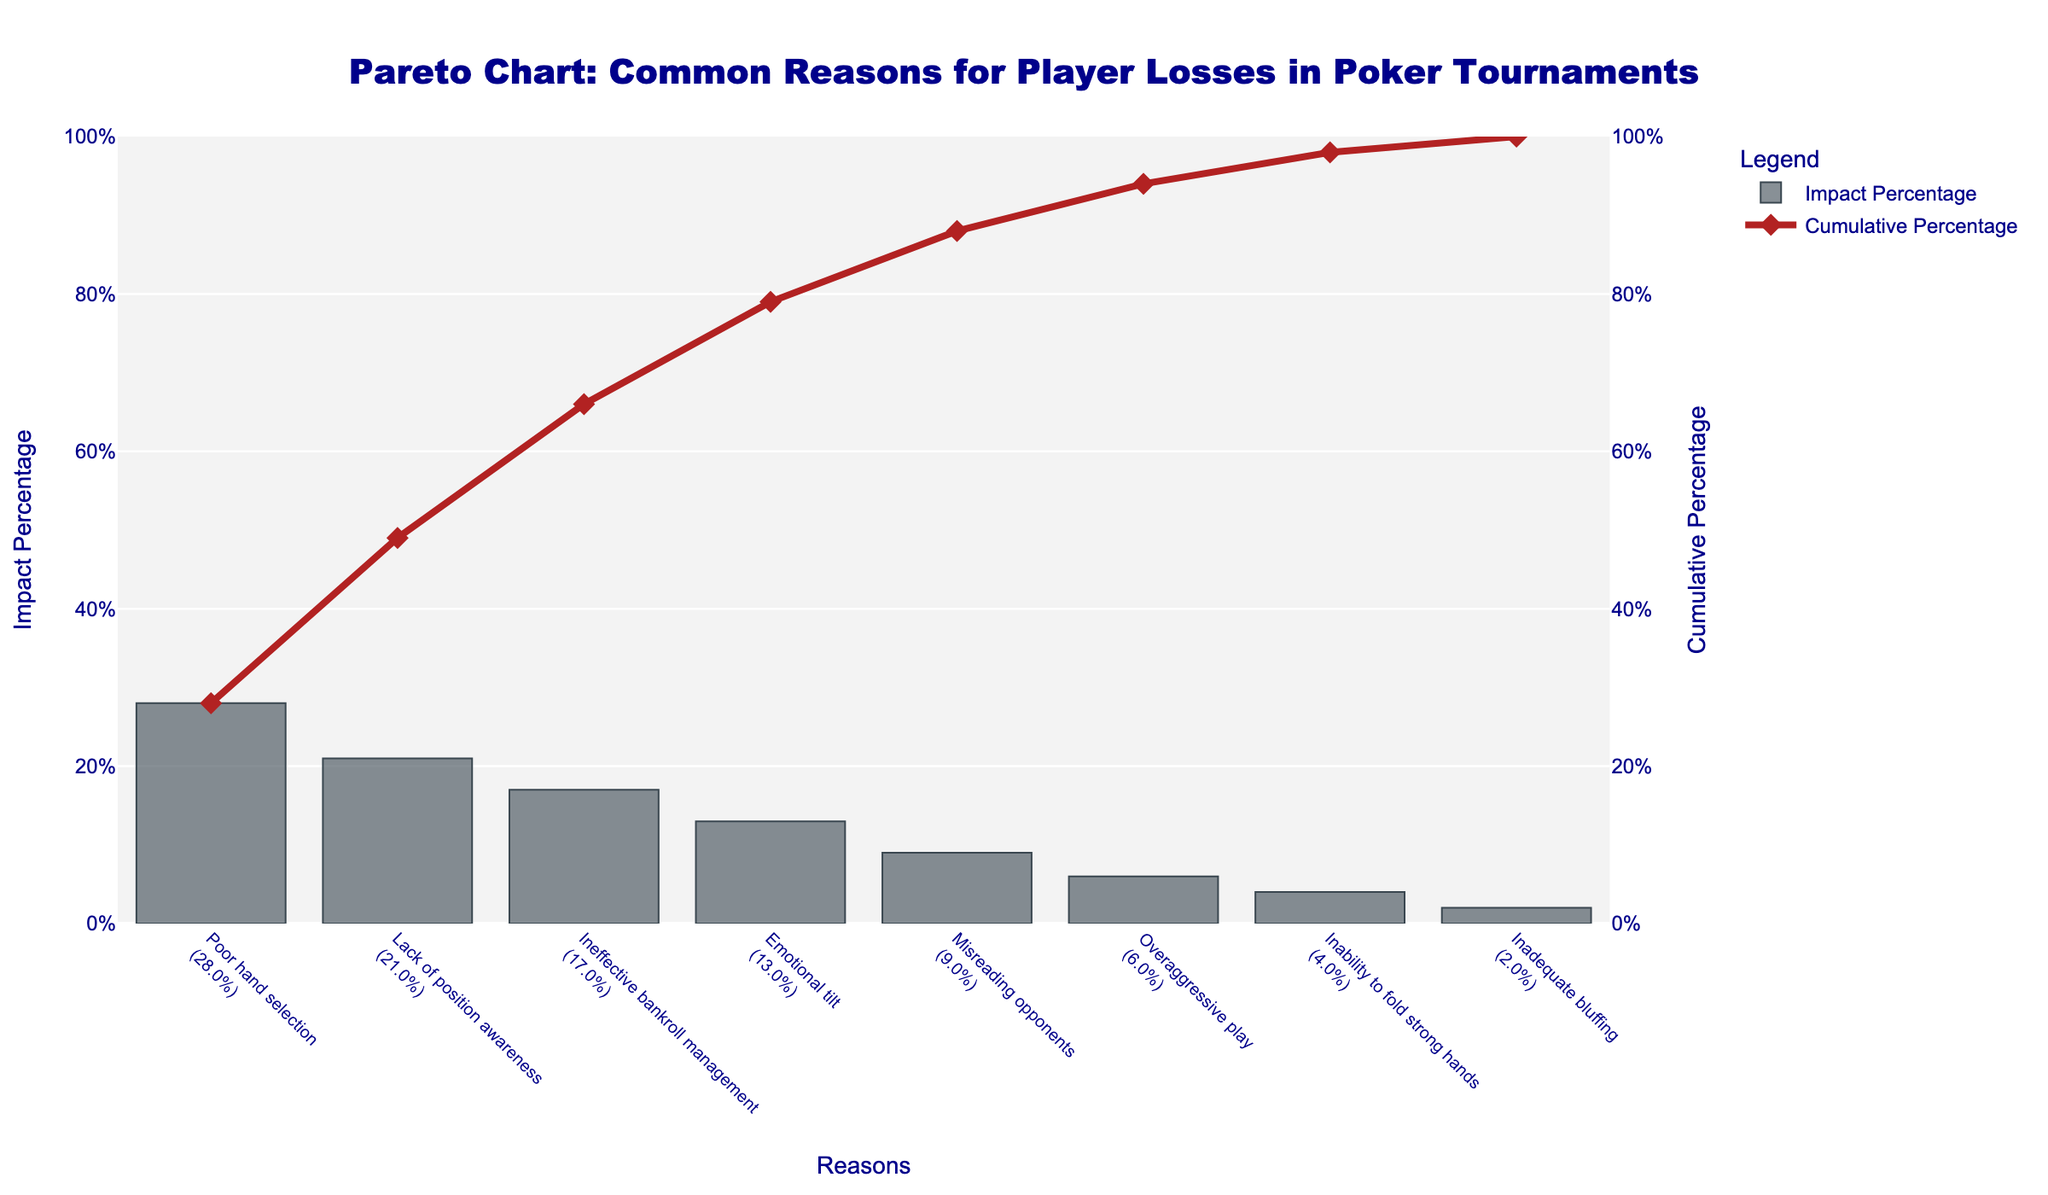What is the title of the Pareto chart? The title is visible at the top of the chart. It provides a summary of what the figure is about.
Answer: "Pareto Chart: Common Reasons for Player Losses in Poker Tournaments" Which reason for player losses has the highest impact percentage? The bar with the greatest height represents "Poor hand selection." It is visually the most striking.
Answer: "Poor hand selection" What color is used to represent the Impact Percentage bars? By observing the bars, you can see they are in shades of gray with a hint of blue.
Answer: Gray with a hint of blue What is the combined impact percentage of the top two reasons for player losses? The percentage for "Poor hand selection" is 28% and for "Lack of position awareness" is 21%. Adding these gives 28% + 21%.
Answer: 49% How much cumulative percentage does "Emotional tilt" contribute? The cumulative percentage is shown by the dots connected by lines, and the value at "Emotional tilt" (13%) needs to be identified.
Answer: 79% Which reason contributes the least to player losses and what is its impact percentage? The smallest bar can be identified as "Inadequate bluffing," and its height gives its impact percentage.
Answer: "Inadequate bluffing", 2% What is the difference between the impact percentage of "Misreading opponents" and "Overaggressive play"? The heights of these two bars provide the percentages which are then subtracted: 9% - 6%.
Answer: 3% What cumulative percentage is reached by the first three reasons for player losses? "Poor hand selection" (28%), "Lack of position awareness" (21%), "Ineffective bankroll management" (17%). Summing these gives 28% + 21% + 17%.
Answer: 66% Between which two reasons does the cumulative percentage cross 50%? Check the cumulative percentage line to see where it surpasses 50%. The first two reasons are "Poor hand selection" and "Lack of position awareness".
Answer: "Poor hand selection" and "Lack of position awareness" Is the cumulative percentage of the top four reasons greater than or less than 80%? Summing the cumulative impact of the top four reasons: 28% + 21% + 17% + 13%. This equals 79%, which is less than 80%.
Answer: Less than 80% 